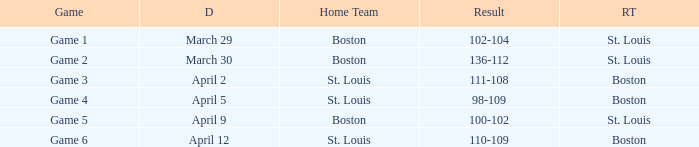What is the Result of Game 3? 111-108. 